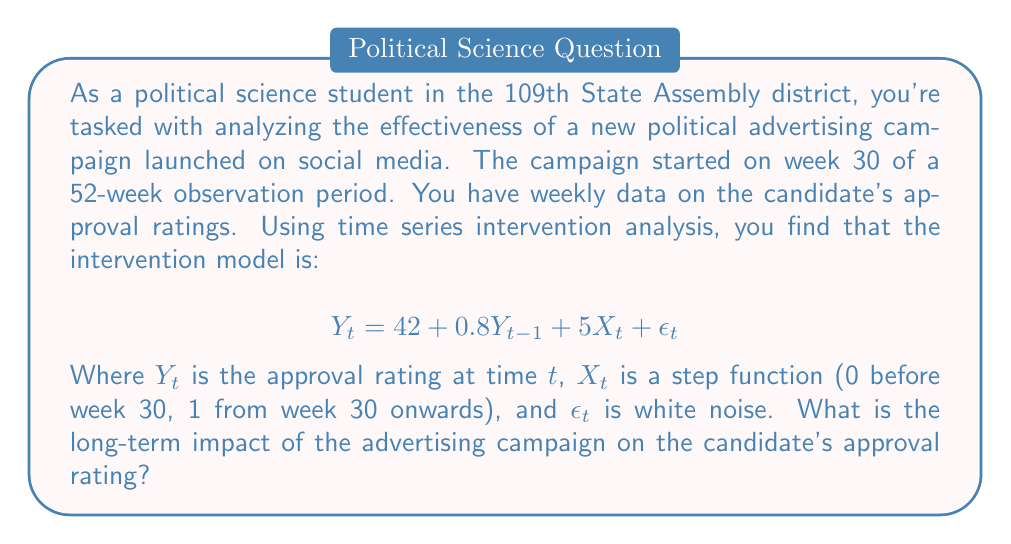Can you solve this math problem? To find the long-term impact of the advertising campaign, we need to calculate the steady-state gain of the intervention. This involves the following steps:

1) In a steady state, $Y_t = Y_{t-1} = Y^*$ (the equilibrium value). Let's substitute this into our model:

   $$Y^* = 42 + 0.8Y^* + 5X^* + \epsilon^*$$

2) In the long run, we assume $\epsilon^* = 0$ (the expected value of white noise is zero). Also, $X^* = 1$ since we're interested in the post-intervention state. So:

   $$Y^* = 42 + 0.8Y^* + 5$$

3) Solve for $Y^*$:

   $$Y^* - 0.8Y^* = 42 + 5$$
   $$0.2Y^* = 47$$
   $$Y^* = 47/0.2 = 235$$

4) This is the long-term equilibrium with the intervention. To find the impact, we need to compare it to the equilibrium without intervention. Set $X^* = 0$ and solve again:

   $$Y^* = 42 + 0.8Y^*$$
   $$0.2Y^* = 42$$
   $$Y^* = 42/0.2 = 210$$

5) The long-term impact is the difference between these two equilibria:

   $$\text{Impact} = 235 - 210 = 25$$

Therefore, the long-term impact of the advertising campaign is an increase of 25 points in the approval rating.
Answer: The long-term impact of the advertising campaign is an increase of 25 points in the candidate's approval rating. 